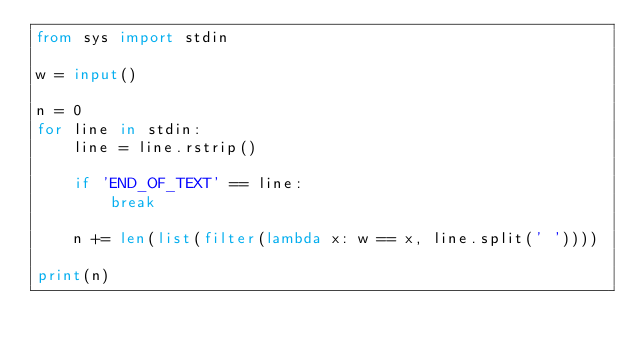<code> <loc_0><loc_0><loc_500><loc_500><_Python_>from sys import stdin

w = input()

n = 0
for line in stdin:
    line = line.rstrip()

    if 'END_OF_TEXT' == line:
        break

    n += len(list(filter(lambda x: w == x, line.split(' '))))

print(n)</code> 